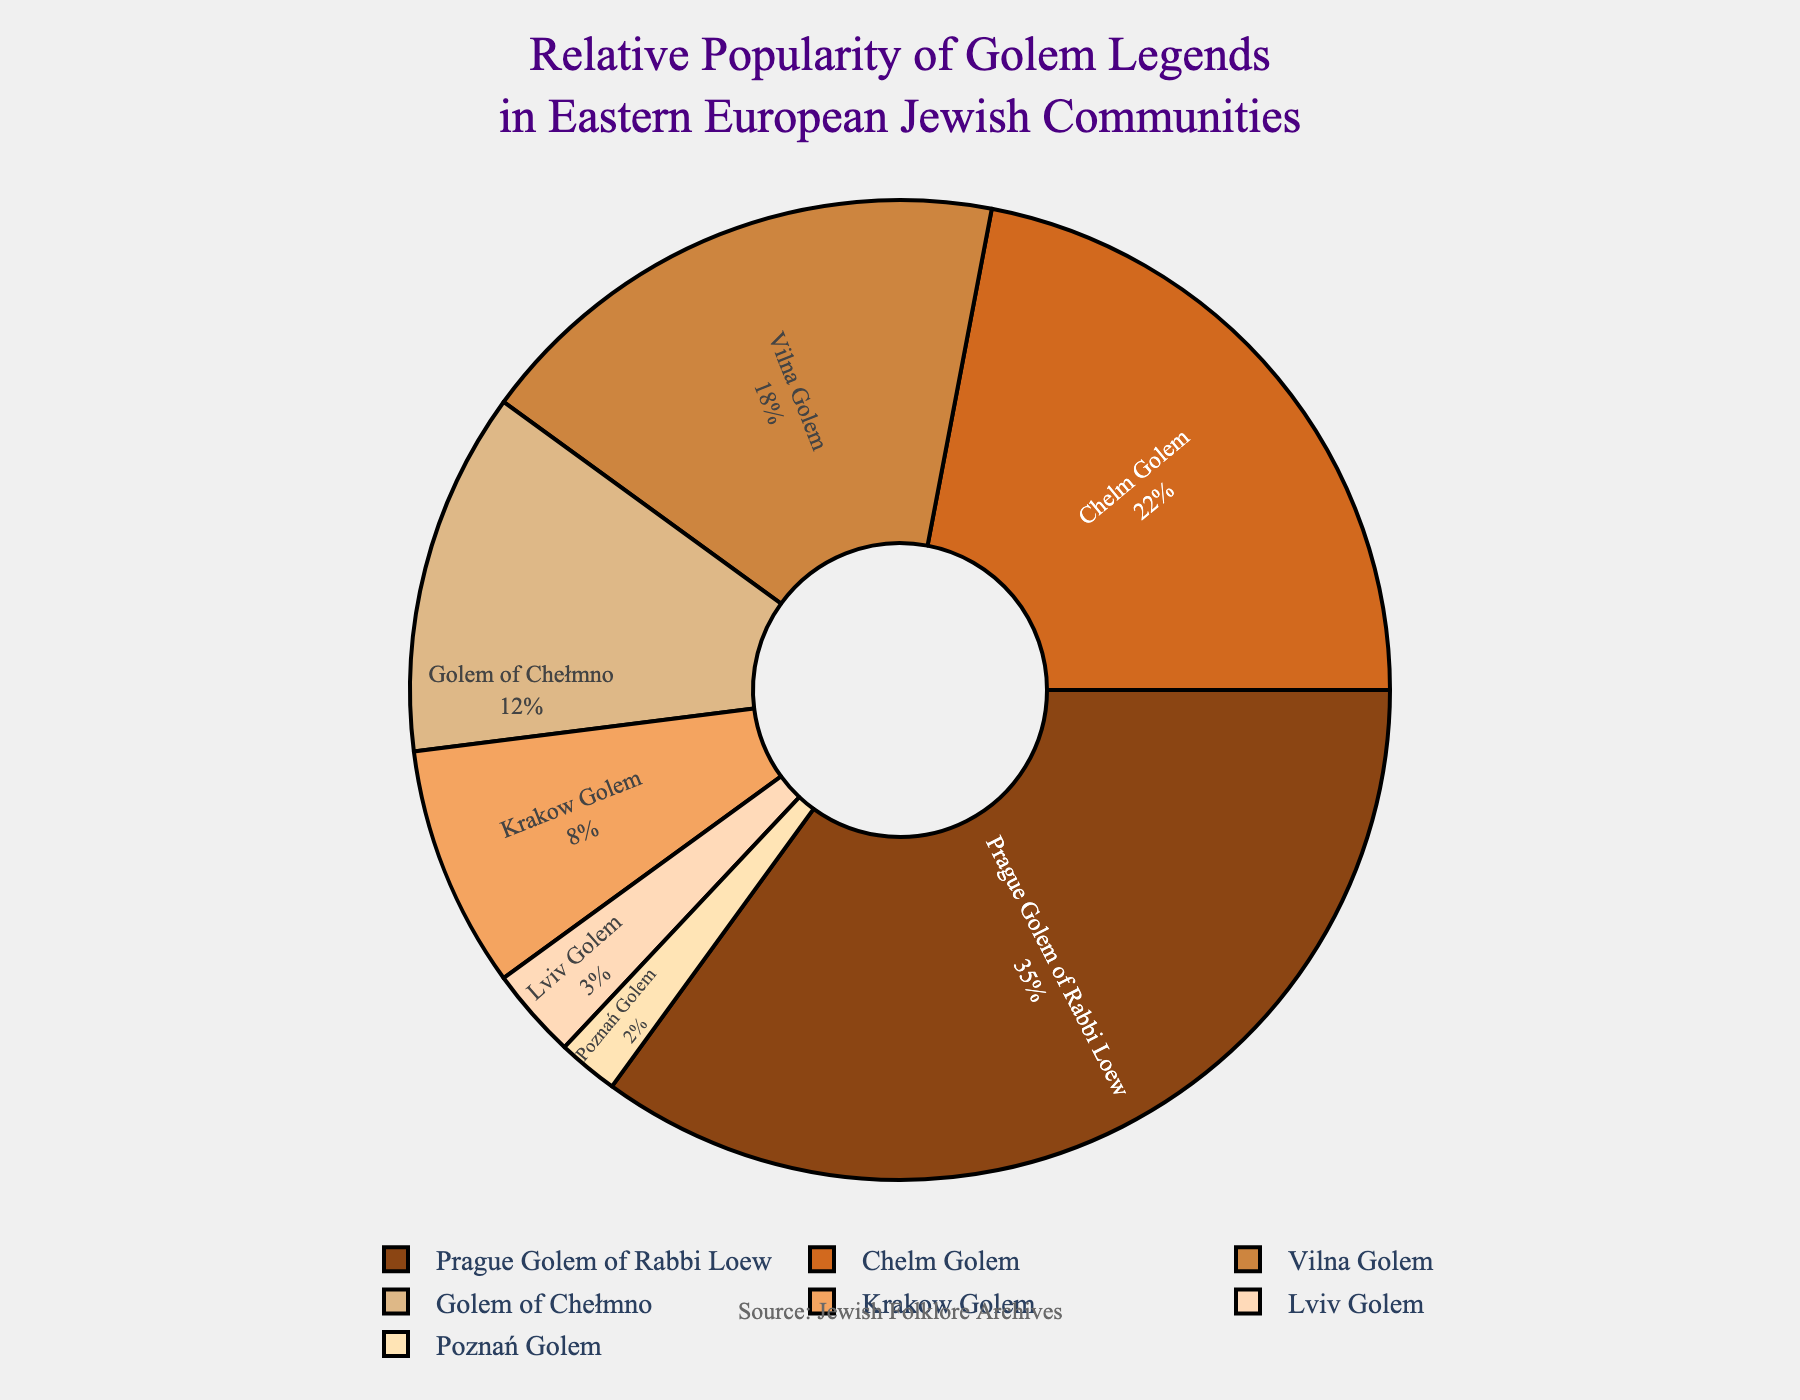Which Golem legend has the highest popularity percentage? The Prague Golem of Rabbi Loew legend tops the list with a 35% share.
Answer: Prague Golem of Rabbi Loew Which is more popular: the Krakow Golem or the Lviv Golem? The Krakow Golem has a higher popularity percentage (8%) compared to the Lviv Golem (3%).
Answer: Krakow Golem What is the combined popularity percentage of the Vilna Golem and the Golem of Chełmno? Combine the Vilna Golem's 18% and the Golem of Chełmno's 12% to get 30%.
Answer: 30% Which legend has the lowest popularity percentage? The Poznań Golem legend has the lowest popularity at 2%.
Answer: Poznań Golem Is the Chelm Golem legend twice as popular as the Vilna Golem legend? The Chelm Golem has a popularity of 22%, which is not twice the 18% popularity of the Vilna Golem.
Answer: No How much more popular is the legend of the Prague Golem compared to the Chelm Golem? Subtract the Chelm Golem's 22% from the Prague Golem's 35% to find a difference of 13%.
Answer: 13% What is the total percentage for all legends except the Prague Golem of Rabbi Loew? Sum the percentages of all other legends (22% + 18% + 12% + 8% + 3% + 2%) to get 65%.
Answer: 65% Which legend has a popularity percentage that is less than 10%? Both the Krakow Golem (8%) and the Lviv Golem (3%) have popularity percentages less than 10%.
Answer: Krakow Golem and Lviv Golem How many legends have a popularity percentage greater than 20%? Only two legends, the Prague Golem of Rabbi Loew (35%) and the Chelm Golem (22%), have percentages greater than 20%.
Answer: Two Are there more legends with popularity percentages above 15% or below 10%? There are three legends above 15% (Prague Golem, Chelm Golem, Vilna Golem) and three legends below 10% (Krakow Golem, Lviv Golem, Poznań Golem), so their counts are equal.
Answer: Equal 